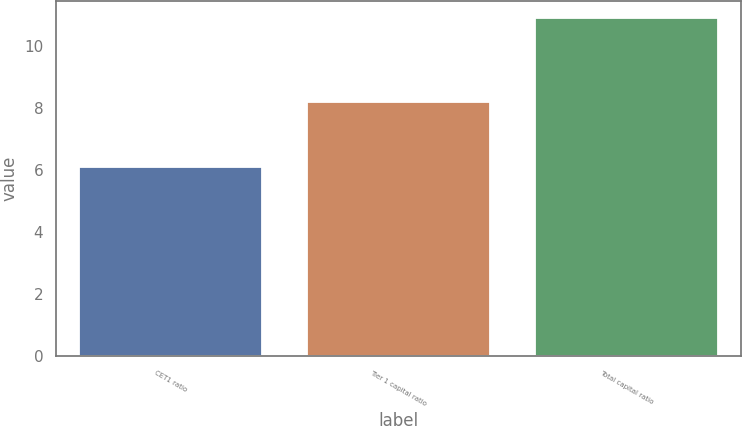Convert chart. <chart><loc_0><loc_0><loc_500><loc_500><bar_chart><fcel>CET1 ratio<fcel>Tier 1 capital ratio<fcel>Total capital ratio<nl><fcel>6.1<fcel>8.2<fcel>10.9<nl></chart> 